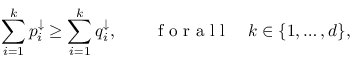Convert formula to latex. <formula><loc_0><loc_0><loc_500><loc_500>\sum _ { i = 1 } ^ { k } p _ { i } ^ { \downarrow } \geq \sum _ { i = 1 } ^ { k } q _ { i } ^ { \downarrow } , \quad f o r a l l \quad k \in \{ 1 , \dots , d \} ,</formula> 